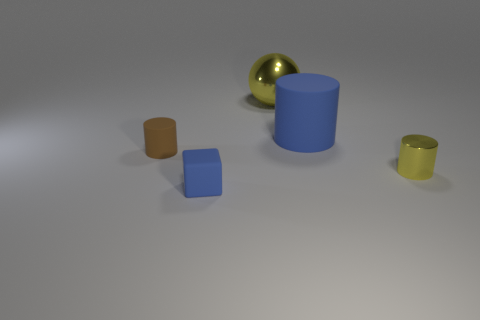There is a tiny object that is the same color as the big cylinder; what shape is it?
Offer a very short reply. Cube. What is the material of the tiny cylinder behind the small yellow cylinder that is on the right side of the large shiny thing?
Make the answer very short. Rubber. Are there any red cylinders that have the same material as the large yellow object?
Offer a very short reply. No. There is a small cylinder right of the big ball; are there any yellow cylinders that are to the left of it?
Offer a very short reply. No. There is a yellow thing that is to the right of the big sphere; what is its material?
Offer a terse response. Metal. Does the large metallic thing have the same shape as the tiny metallic object?
Offer a very short reply. No. The cylinder behind the small cylinder that is on the left side of the blue thing that is in front of the tiny brown cylinder is what color?
Offer a very short reply. Blue. What number of gray metal objects have the same shape as the small yellow object?
Provide a short and direct response. 0. What is the size of the blue matte object in front of the shiny object that is in front of the big yellow shiny sphere?
Provide a short and direct response. Small. Do the brown matte cylinder and the yellow metal ball have the same size?
Your answer should be compact. No. 